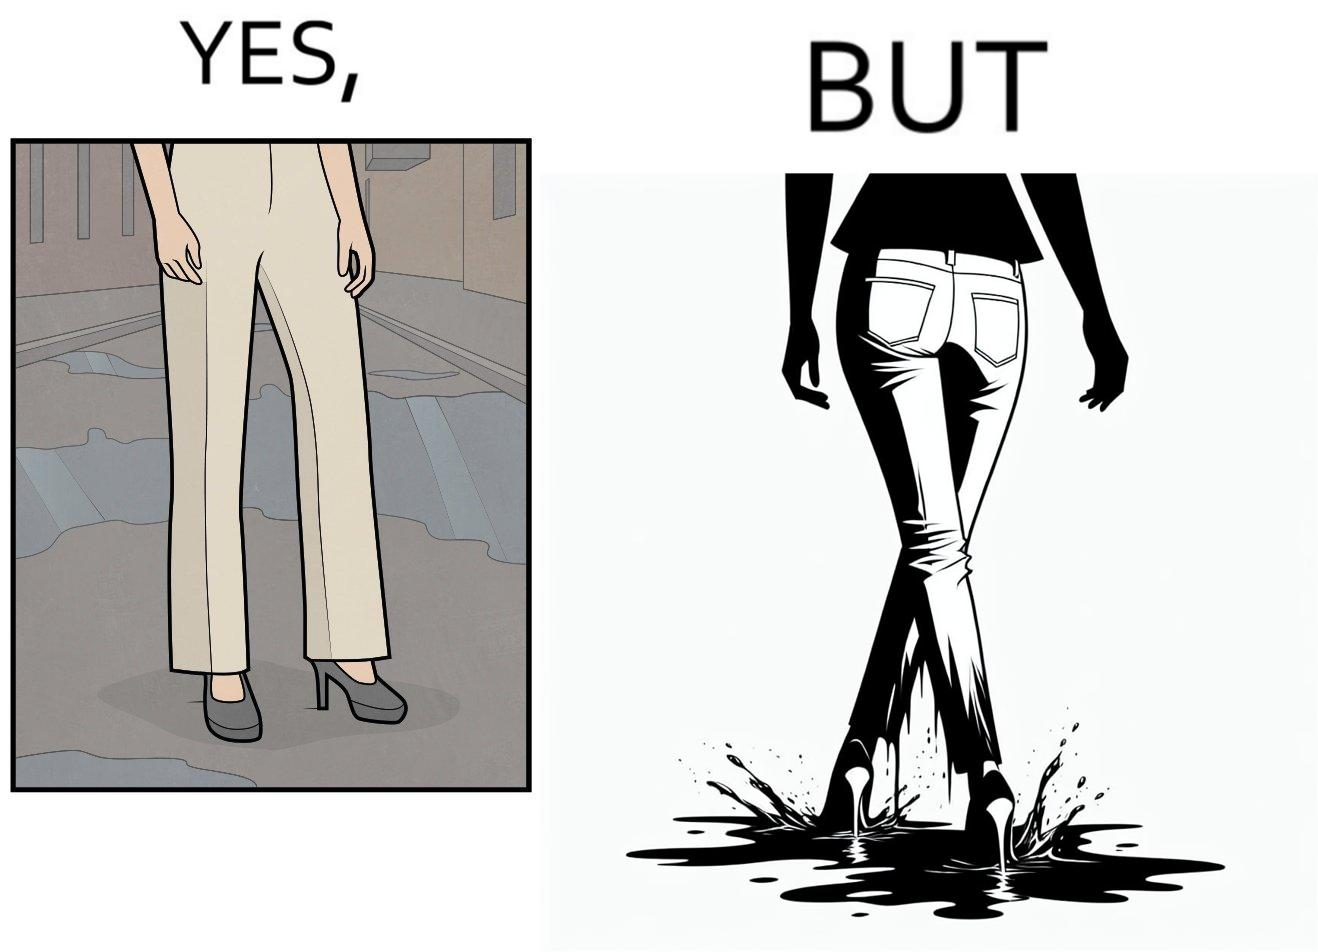Is this image satirical or non-satirical? Yes, this image is satirical. 